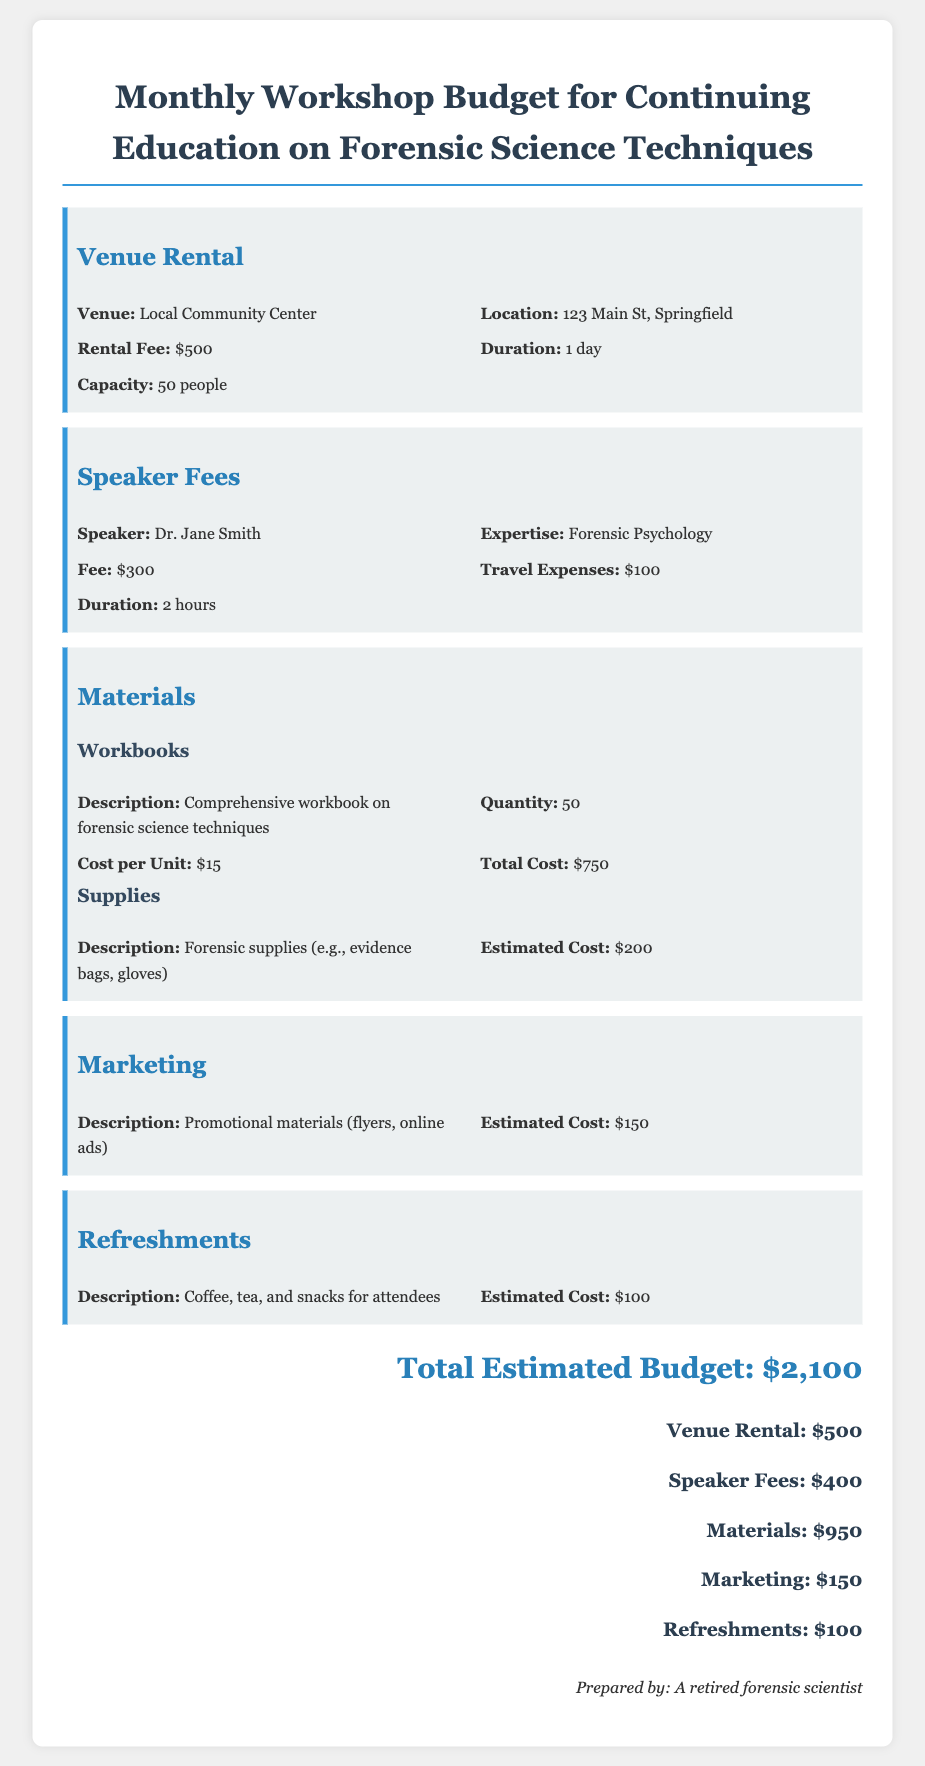What is the venue for the workshop? The venue for the workshop is specified in the document as the Local Community Center.
Answer: Local Community Center What is the speaker's expertise? The document mentions that the speaker, Dr. Jane Smith, has expertise in Forensic Psychology.
Answer: Forensic Psychology How much is the rental fee for the venue? The rental fee for the venue is clearly stated in the document as $500.
Answer: $500 What are the total costs for materials? The total cost for materials includes workbooks and supplies, which adds up to $950.
Answer: $950 What is the estimated cost for refreshments? The document specifies the estimated cost for refreshments as $100.
Answer: $100 How long is the speaker scheduled to speak? The duration of the speaker's session is detailed in the document as 2 hours.
Answer: 2 hours What is the total estimated budget for the workshop? The total estimated budget is summarized at the end of the document, which is $2,100.
Answer: $2,100 Which items are included in the materials section? The materials section includes workbooks and forensic supplies as detailed in the document.
Answer: Workbooks, forensic supplies What type of promotional materials are mentioned? The document lists promotional materials such as flyers and online ads in the marketing section.
Answer: Flyers, online ads Who prepared the document? The document states that it was prepared by a retired forensic scientist.
Answer: A retired forensic scientist 